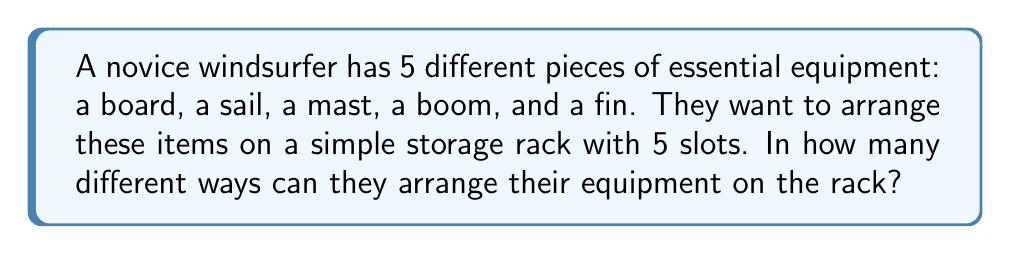Could you help me with this problem? Let's approach this step-by-step:

1) This is a permutation problem. We are arranging all 5 items in a specific order, and each item can only be used once.

2) The formula for permutations of n distinct objects is:

   $$P(n) = n!$$

   Where $n!$ represents the factorial of n.

3) In this case, we have 5 distinct pieces of equipment, so $n = 5$.

4) Let's calculate $5!$:

   $$5! = 5 \times 4 \times 3 \times 2 \times 1 = 120$$

5) Therefore, there are 120 different ways to arrange the 5 pieces of windsurfing equipment on the storage rack.

This simple arrangement allows the beginner windsurfer to easily count and check their equipment, ensuring reliability in their setup.
Answer: $120$ ways 